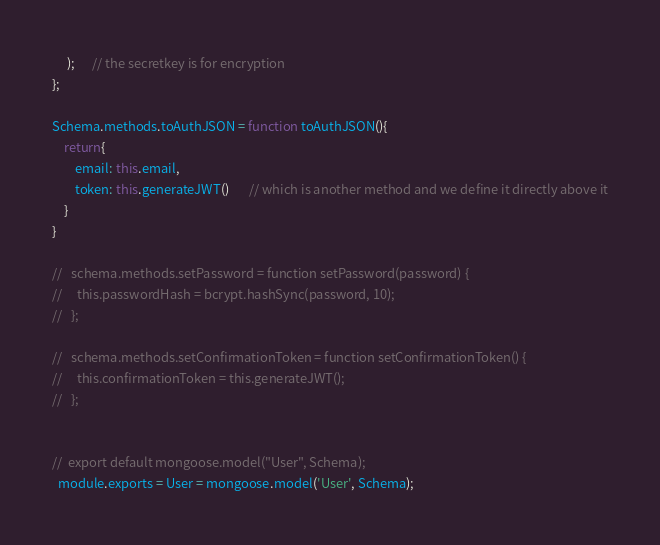Convert code to text. <code><loc_0><loc_0><loc_500><loc_500><_JavaScript_>     );      // the secretkey is for encryption
};

Schema.methods.toAuthJSON = function toAuthJSON(){
    return{
        email: this.email,
        token: this.generateJWT()       // which is another method and we define it directly above it
    }
}
  
//   schema.methods.setPassword = function setPassword(password) {
//     this.passwordHash = bcrypt.hashSync(password, 10);
//   };
  
//   schema.methods.setConfirmationToken = function setConfirmationToken() {
//     this.confirmationToken = this.generateJWT();
//   };
  

//  export default mongoose.model("User", Schema);
  module.exports = User = mongoose.model('User', Schema);</code> 